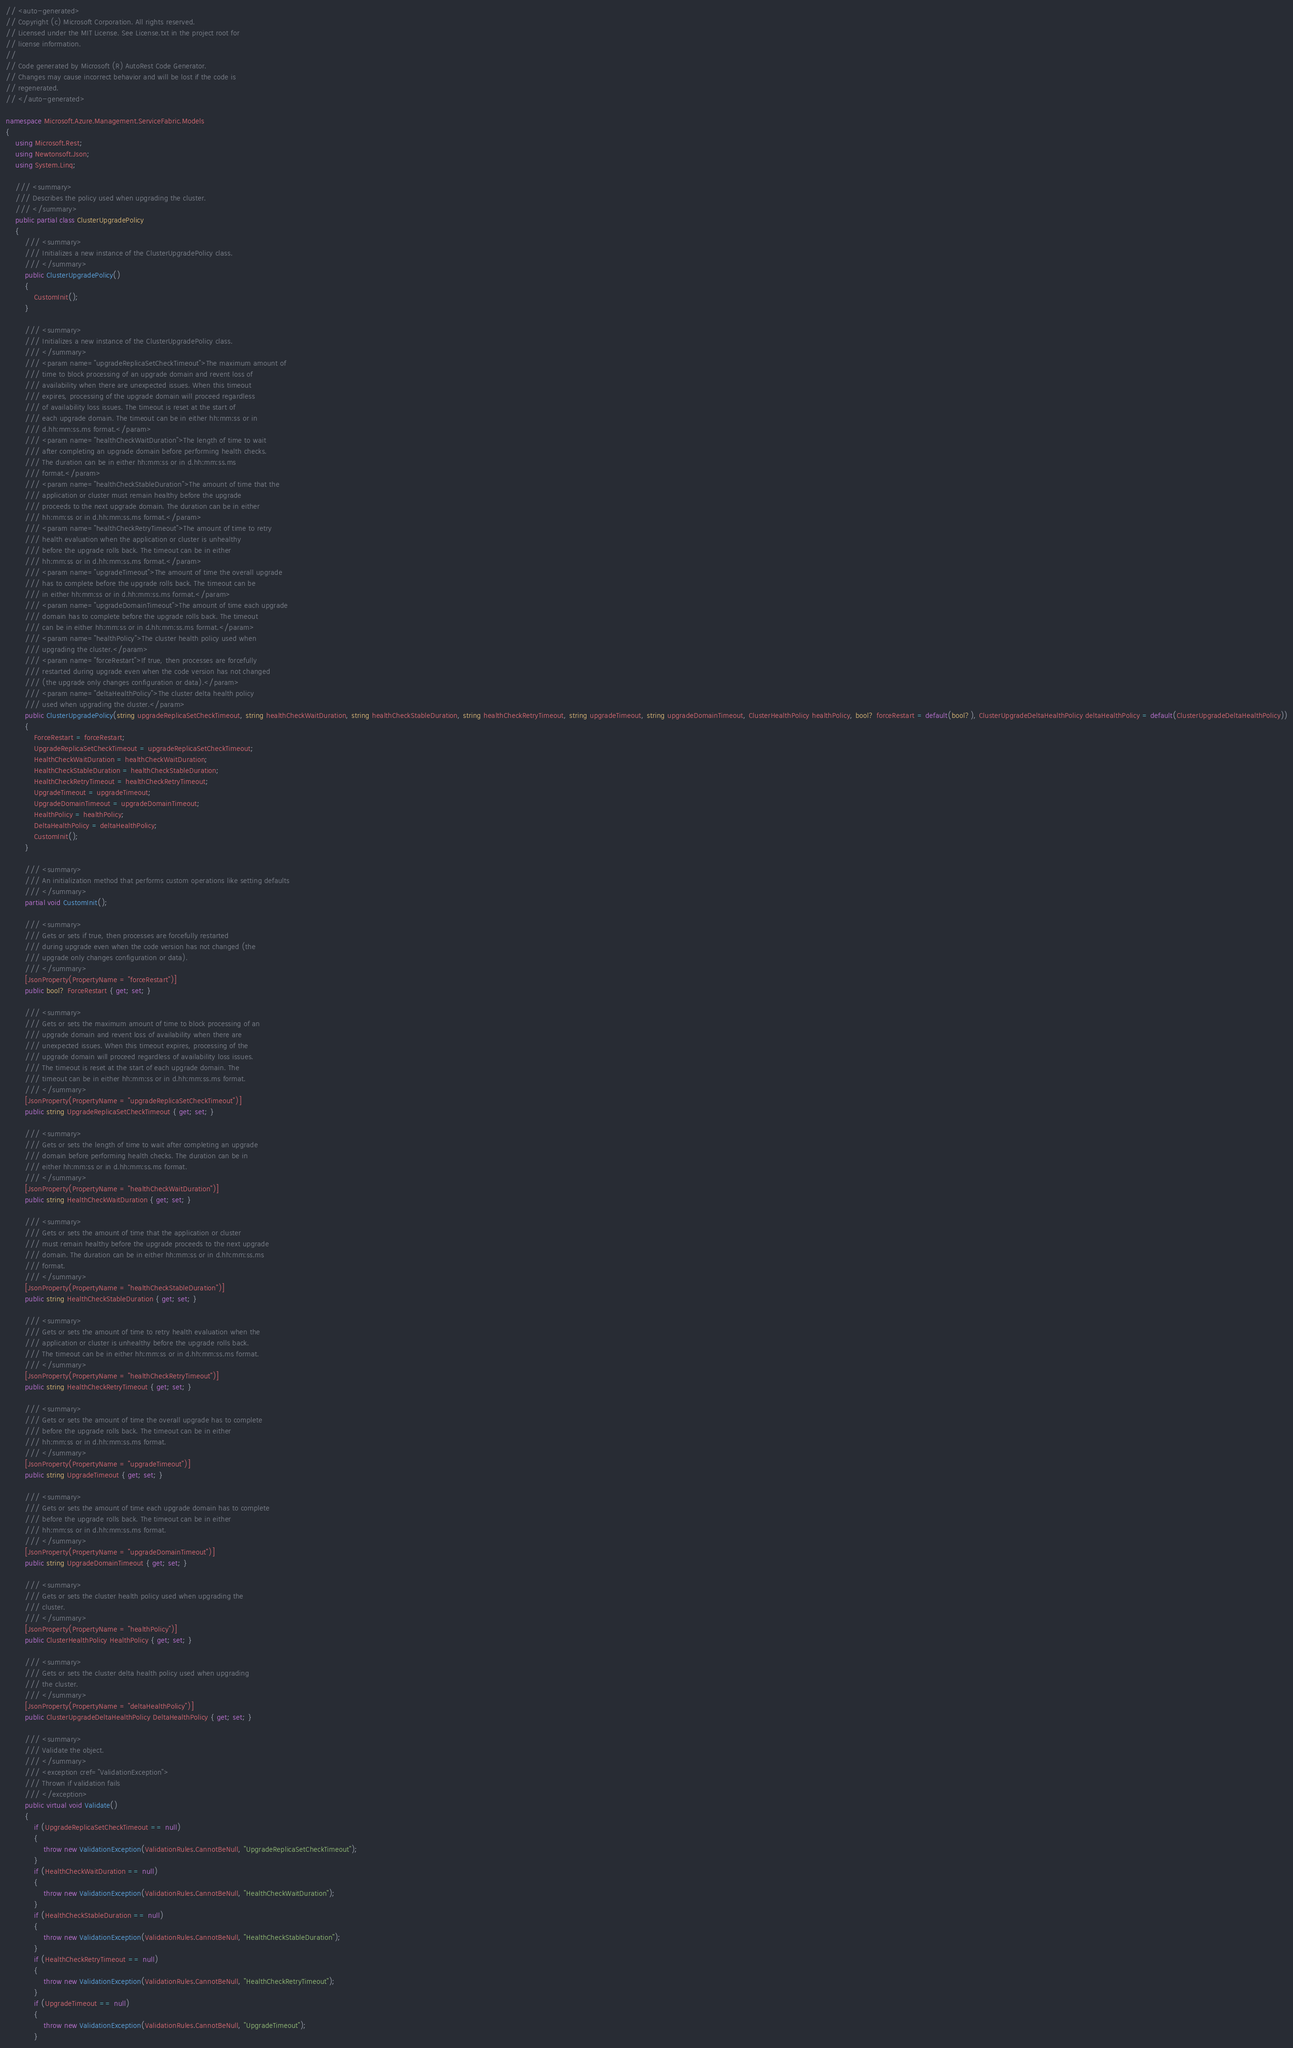Convert code to text. <code><loc_0><loc_0><loc_500><loc_500><_C#_>// <auto-generated>
// Copyright (c) Microsoft Corporation. All rights reserved.
// Licensed under the MIT License. See License.txt in the project root for
// license information.
//
// Code generated by Microsoft (R) AutoRest Code Generator.
// Changes may cause incorrect behavior and will be lost if the code is
// regenerated.
// </auto-generated>

namespace Microsoft.Azure.Management.ServiceFabric.Models
{
    using Microsoft.Rest;
    using Newtonsoft.Json;
    using System.Linq;

    /// <summary>
    /// Describes the policy used when upgrading the cluster.
    /// </summary>
    public partial class ClusterUpgradePolicy
    {
        /// <summary>
        /// Initializes a new instance of the ClusterUpgradePolicy class.
        /// </summary>
        public ClusterUpgradePolicy()
        {
            CustomInit();
        }

        /// <summary>
        /// Initializes a new instance of the ClusterUpgradePolicy class.
        /// </summary>
        /// <param name="upgradeReplicaSetCheckTimeout">The maximum amount of
        /// time to block processing of an upgrade domain and revent loss of
        /// availability when there are unexpected issues. When this timeout
        /// expires, processing of the upgrade domain will proceed regardless
        /// of availability loss issues. The timeout is reset at the start of
        /// each upgrade domain. The timeout can be in either hh:mm:ss or in
        /// d.hh:mm:ss.ms format.</param>
        /// <param name="healthCheckWaitDuration">The length of time to wait
        /// after completing an upgrade domain before performing health checks.
        /// The duration can be in either hh:mm:ss or in d.hh:mm:ss.ms
        /// format.</param>
        /// <param name="healthCheckStableDuration">The amount of time that the
        /// application or cluster must remain healthy before the upgrade
        /// proceeds to the next upgrade domain. The duration can be in either
        /// hh:mm:ss or in d.hh:mm:ss.ms format.</param>
        /// <param name="healthCheckRetryTimeout">The amount of time to retry
        /// health evaluation when the application or cluster is unhealthy
        /// before the upgrade rolls back. The timeout can be in either
        /// hh:mm:ss or in d.hh:mm:ss.ms format.</param>
        /// <param name="upgradeTimeout">The amount of time the overall upgrade
        /// has to complete before the upgrade rolls back. The timeout can be
        /// in either hh:mm:ss or in d.hh:mm:ss.ms format.</param>
        /// <param name="upgradeDomainTimeout">The amount of time each upgrade
        /// domain has to complete before the upgrade rolls back. The timeout
        /// can be in either hh:mm:ss or in d.hh:mm:ss.ms format.</param>
        /// <param name="healthPolicy">The cluster health policy used when
        /// upgrading the cluster.</param>
        /// <param name="forceRestart">If true, then processes are forcefully
        /// restarted during upgrade even when the code version has not changed
        /// (the upgrade only changes configuration or data).</param>
        /// <param name="deltaHealthPolicy">The cluster delta health policy
        /// used when upgrading the cluster.</param>
        public ClusterUpgradePolicy(string upgradeReplicaSetCheckTimeout, string healthCheckWaitDuration, string healthCheckStableDuration, string healthCheckRetryTimeout, string upgradeTimeout, string upgradeDomainTimeout, ClusterHealthPolicy healthPolicy, bool? forceRestart = default(bool?), ClusterUpgradeDeltaHealthPolicy deltaHealthPolicy = default(ClusterUpgradeDeltaHealthPolicy))
        {
            ForceRestart = forceRestart;
            UpgradeReplicaSetCheckTimeout = upgradeReplicaSetCheckTimeout;
            HealthCheckWaitDuration = healthCheckWaitDuration;
            HealthCheckStableDuration = healthCheckStableDuration;
            HealthCheckRetryTimeout = healthCheckRetryTimeout;
            UpgradeTimeout = upgradeTimeout;
            UpgradeDomainTimeout = upgradeDomainTimeout;
            HealthPolicy = healthPolicy;
            DeltaHealthPolicy = deltaHealthPolicy;
            CustomInit();
        }

        /// <summary>
        /// An initialization method that performs custom operations like setting defaults
        /// </summary>
        partial void CustomInit();

        /// <summary>
        /// Gets or sets if true, then processes are forcefully restarted
        /// during upgrade even when the code version has not changed (the
        /// upgrade only changes configuration or data).
        /// </summary>
        [JsonProperty(PropertyName = "forceRestart")]
        public bool? ForceRestart { get; set; }

        /// <summary>
        /// Gets or sets the maximum amount of time to block processing of an
        /// upgrade domain and revent loss of availability when there are
        /// unexpected issues. When this timeout expires, processing of the
        /// upgrade domain will proceed regardless of availability loss issues.
        /// The timeout is reset at the start of each upgrade domain. The
        /// timeout can be in either hh:mm:ss or in d.hh:mm:ss.ms format.
        /// </summary>
        [JsonProperty(PropertyName = "upgradeReplicaSetCheckTimeout")]
        public string UpgradeReplicaSetCheckTimeout { get; set; }

        /// <summary>
        /// Gets or sets the length of time to wait after completing an upgrade
        /// domain before performing health checks. The duration can be in
        /// either hh:mm:ss or in d.hh:mm:ss.ms format.
        /// </summary>
        [JsonProperty(PropertyName = "healthCheckWaitDuration")]
        public string HealthCheckWaitDuration { get; set; }

        /// <summary>
        /// Gets or sets the amount of time that the application or cluster
        /// must remain healthy before the upgrade proceeds to the next upgrade
        /// domain. The duration can be in either hh:mm:ss or in d.hh:mm:ss.ms
        /// format.
        /// </summary>
        [JsonProperty(PropertyName = "healthCheckStableDuration")]
        public string HealthCheckStableDuration { get; set; }

        /// <summary>
        /// Gets or sets the amount of time to retry health evaluation when the
        /// application or cluster is unhealthy before the upgrade rolls back.
        /// The timeout can be in either hh:mm:ss or in d.hh:mm:ss.ms format.
        /// </summary>
        [JsonProperty(PropertyName = "healthCheckRetryTimeout")]
        public string HealthCheckRetryTimeout { get; set; }

        /// <summary>
        /// Gets or sets the amount of time the overall upgrade has to complete
        /// before the upgrade rolls back. The timeout can be in either
        /// hh:mm:ss or in d.hh:mm:ss.ms format.
        /// </summary>
        [JsonProperty(PropertyName = "upgradeTimeout")]
        public string UpgradeTimeout { get; set; }

        /// <summary>
        /// Gets or sets the amount of time each upgrade domain has to complete
        /// before the upgrade rolls back. The timeout can be in either
        /// hh:mm:ss or in d.hh:mm:ss.ms format.
        /// </summary>
        [JsonProperty(PropertyName = "upgradeDomainTimeout")]
        public string UpgradeDomainTimeout { get; set; }

        /// <summary>
        /// Gets or sets the cluster health policy used when upgrading the
        /// cluster.
        /// </summary>
        [JsonProperty(PropertyName = "healthPolicy")]
        public ClusterHealthPolicy HealthPolicy { get; set; }

        /// <summary>
        /// Gets or sets the cluster delta health policy used when upgrading
        /// the cluster.
        /// </summary>
        [JsonProperty(PropertyName = "deltaHealthPolicy")]
        public ClusterUpgradeDeltaHealthPolicy DeltaHealthPolicy { get; set; }

        /// <summary>
        /// Validate the object.
        /// </summary>
        /// <exception cref="ValidationException">
        /// Thrown if validation fails
        /// </exception>
        public virtual void Validate()
        {
            if (UpgradeReplicaSetCheckTimeout == null)
            {
                throw new ValidationException(ValidationRules.CannotBeNull, "UpgradeReplicaSetCheckTimeout");
            }
            if (HealthCheckWaitDuration == null)
            {
                throw new ValidationException(ValidationRules.CannotBeNull, "HealthCheckWaitDuration");
            }
            if (HealthCheckStableDuration == null)
            {
                throw new ValidationException(ValidationRules.CannotBeNull, "HealthCheckStableDuration");
            }
            if (HealthCheckRetryTimeout == null)
            {
                throw new ValidationException(ValidationRules.CannotBeNull, "HealthCheckRetryTimeout");
            }
            if (UpgradeTimeout == null)
            {
                throw new ValidationException(ValidationRules.CannotBeNull, "UpgradeTimeout");
            }</code> 